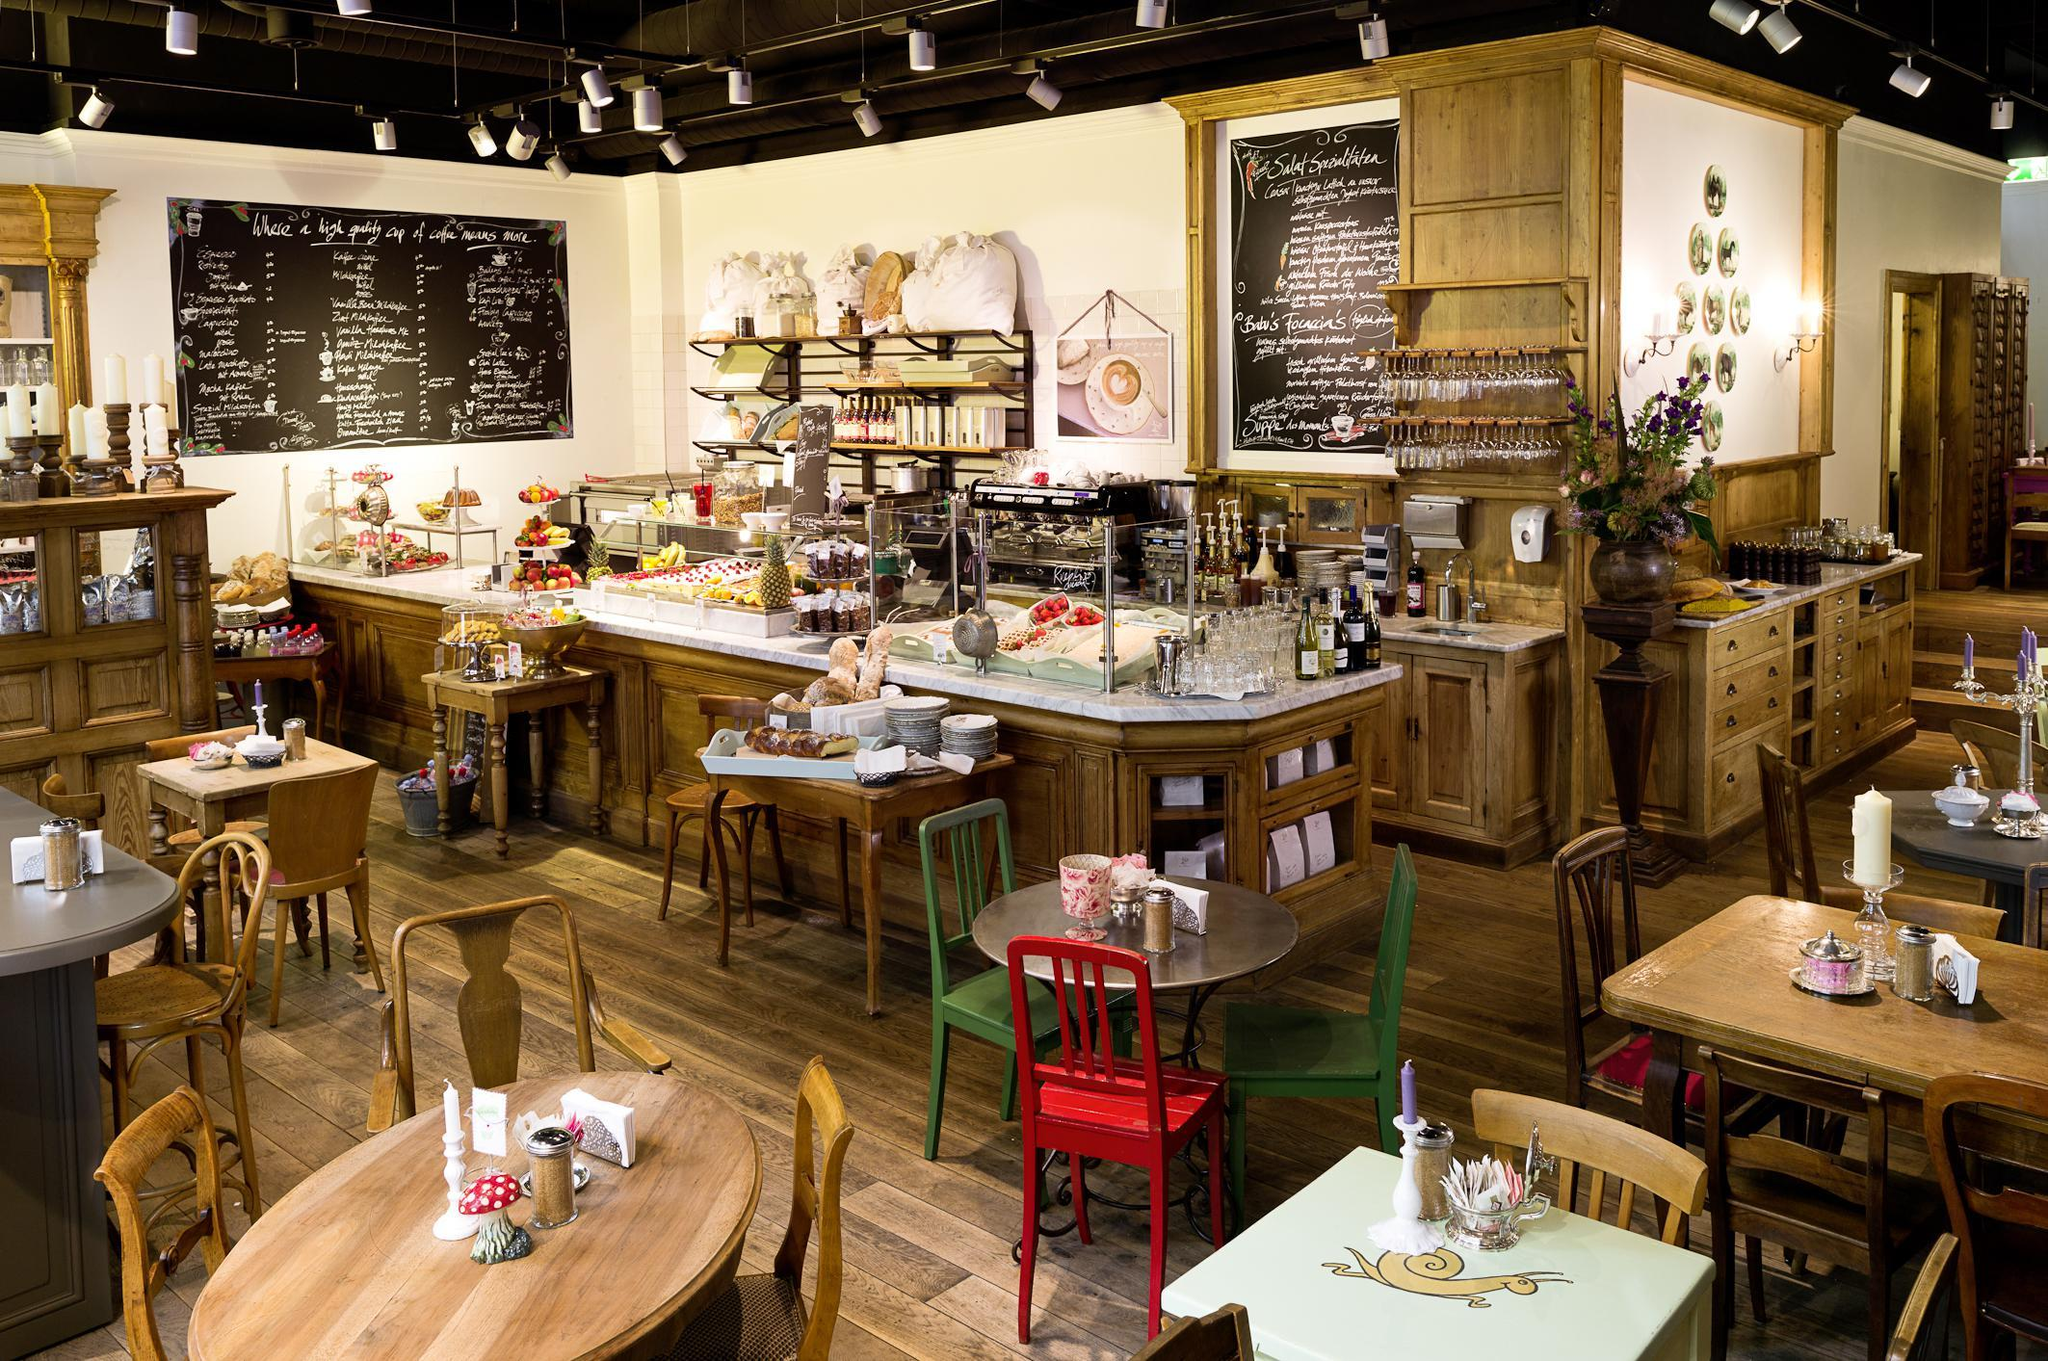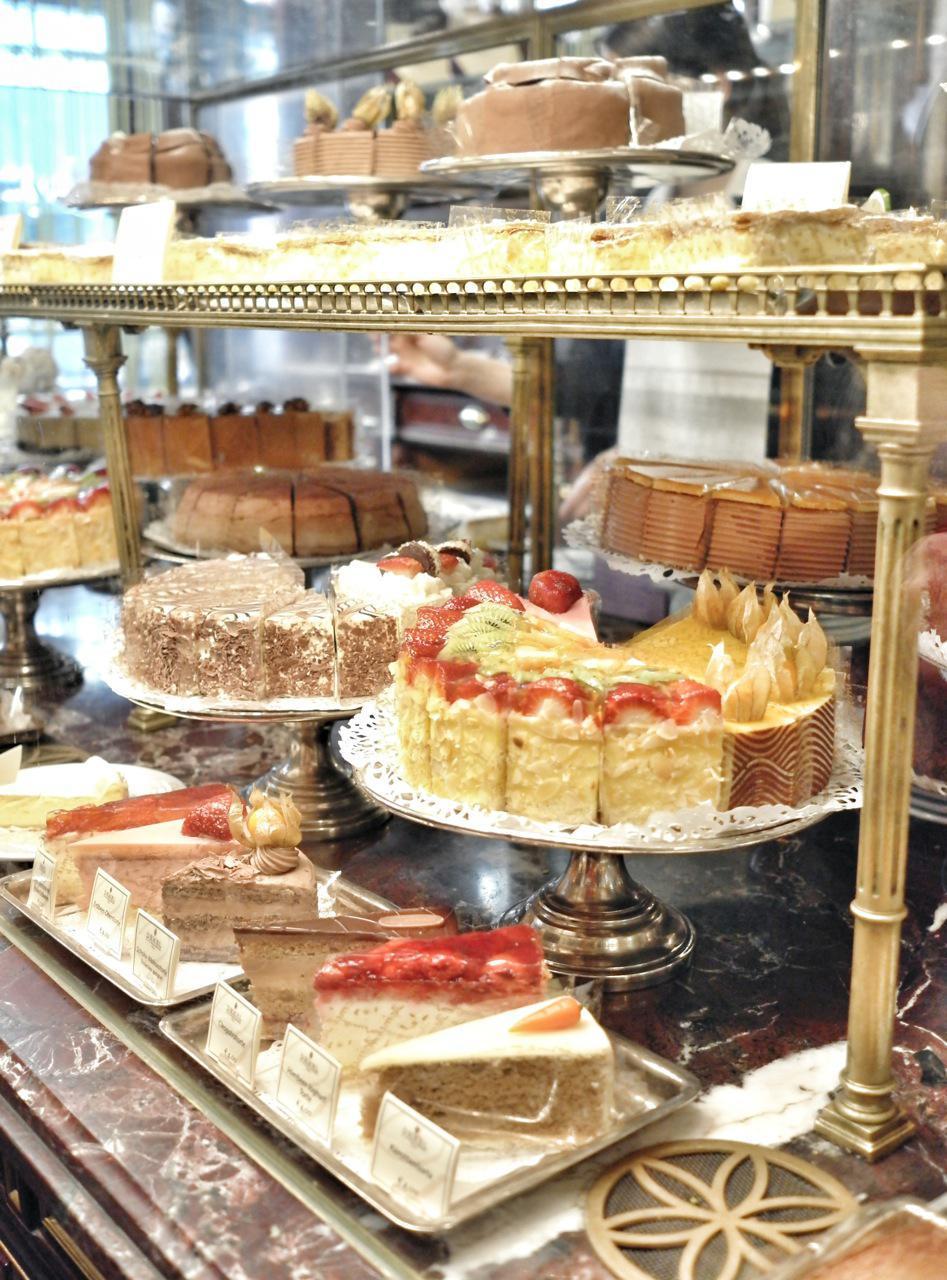The first image is the image on the left, the second image is the image on the right. Analyze the images presented: Is the assertion "In the image to the right, at least one cake has strawberry on it." valid? Answer yes or no. Yes. The first image is the image on the left, the second image is the image on the right. For the images shown, is this caption "An image features cakes on pedestal stands under a top tier supported by ornate columns with more cakes on pedestals." true? Answer yes or no. Yes. 